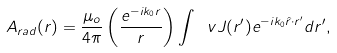Convert formula to latex. <formula><loc_0><loc_0><loc_500><loc_500>A _ { r a d } ( r ) = \frac { \mu _ { o } } { 4 \pi } \left ( \frac { e ^ { - i k _ { 0 } r } } { r } \right ) \int \ v J ( r ^ { \prime } ) e ^ { - i k _ { 0 } \hat { r } \cdot r ^ { \prime } } d r ^ { \prime } ,</formula> 